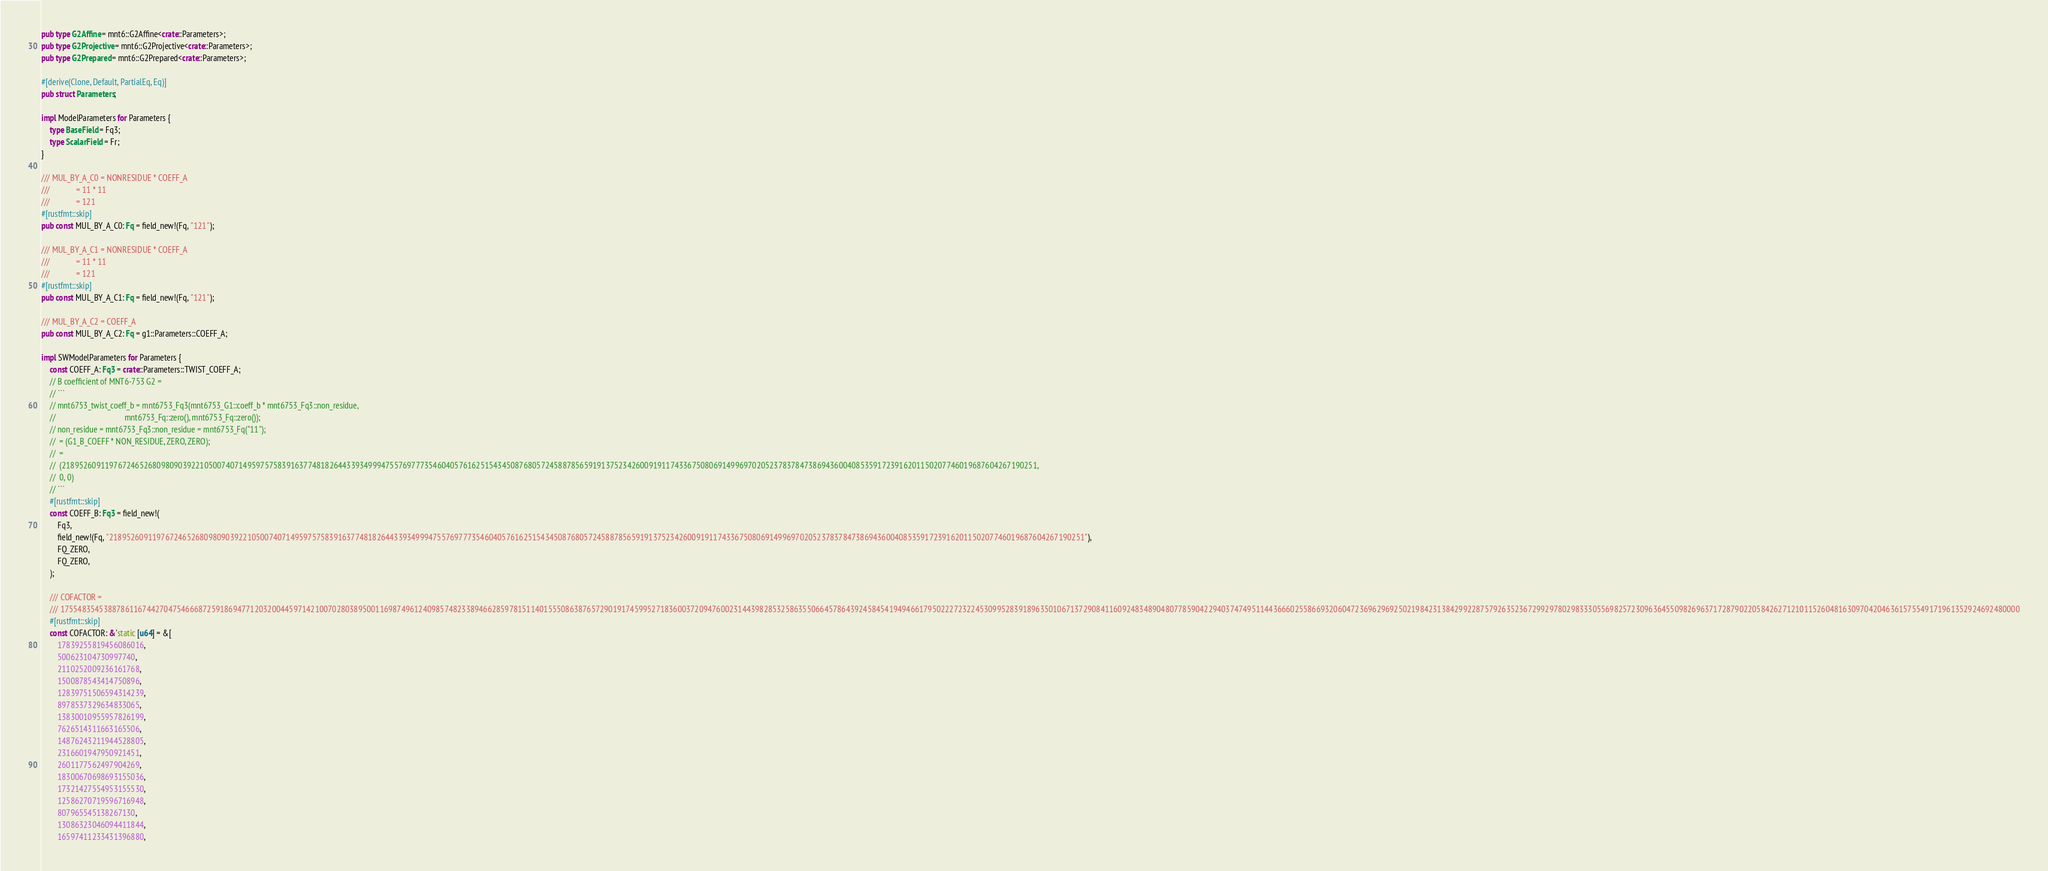Convert code to text. <code><loc_0><loc_0><loc_500><loc_500><_Rust_>
pub type G2Affine = mnt6::G2Affine<crate::Parameters>;
pub type G2Projective = mnt6::G2Projective<crate::Parameters>;
pub type G2Prepared = mnt6::G2Prepared<crate::Parameters>;

#[derive(Clone, Default, PartialEq, Eq)]
pub struct Parameters;

impl ModelParameters for Parameters {
    type BaseField = Fq3;
    type ScalarField = Fr;
}

/// MUL_BY_A_C0 = NONRESIDUE * COEFF_A
///             = 11 * 11
///             = 121
#[rustfmt::skip]
pub const MUL_BY_A_C0: Fq = field_new!(Fq, "121");

/// MUL_BY_A_C1 = NONRESIDUE * COEFF_A
///             = 11 * 11
///             = 121
#[rustfmt::skip]
pub const MUL_BY_A_C1: Fq = field_new!(Fq, "121");

/// MUL_BY_A_C2 = COEFF_A
pub const MUL_BY_A_C2: Fq = g1::Parameters::COEFF_A;

impl SWModelParameters for Parameters {
    const COEFF_A: Fq3 = crate::Parameters::TWIST_COEFF_A;
    // B coefficient of MNT6-753 G2 =
    // ```
    // mnt6753_twist_coeff_b = mnt6753_Fq3(mnt6753_G1::coeff_b * mnt6753_Fq3::non_residue,
    //                                  mnt6753_Fq::zero(), mnt6753_Fq::zero());
    // non_residue = mnt6753_Fq3::non_residue = mnt6753_Fq("11");
    //  = (G1_B_COEFF * NON_RESIDUE, ZERO, ZERO);
    //  =
    //  (2189526091197672465268098090392210500740714959757583916377481826443393499947557697773546040576162515434508768057245887856591913752342600919117433675080691499697020523783784738694360040853591723916201150207746019687604267190251,
    //  0, 0)
    // ```
    #[rustfmt::skip]
    const COEFF_B: Fq3 = field_new!(
        Fq3,
        field_new!(Fq, "2189526091197672465268098090392210500740714959757583916377481826443393499947557697773546040576162515434508768057245887856591913752342600919117433675080691499697020523783784738694360040853591723916201150207746019687604267190251"),
        FQ_ZERO,
        FQ_ZERO,
    );

    /// COFACTOR =
    /// 1755483545388786116744270475466687259186947712032004459714210070280389500116987496124098574823389466285978151140155508638765729019174599527183600372094760023144398285325863550664578643924584541949466179502227232245309952839189635010671372908411609248348904807785904229403747495114436660255866932060472369629692502198423138429922875792635236729929780298333055698257230963645509826963717287902205842627121011526048163097042046361575549171961352924692480000
    #[rustfmt::skip]
    const COFACTOR: &'static [u64] = &[
        17839255819456086016,
        500623104730997740,
        2110252009236161768,
        1500878543414750896,
        12839751506594314239,
        8978537329634833065,
        13830010955957826199,
        7626514311663165506,
        14876243211944528805,
        2316601947950921451,
        2601177562497904269,
        18300670698693155036,
        17321427554953155530,
        12586270719596716948,
        807965545138267130,
        13086323046094411844,
        16597411233431396880,</code> 